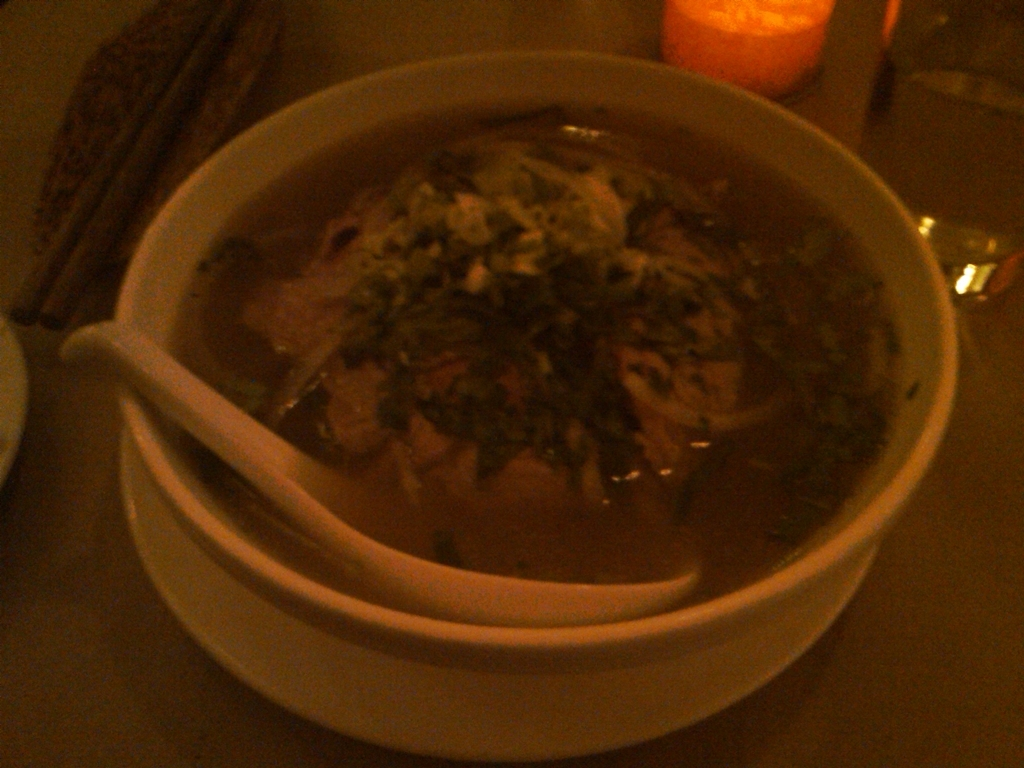Can you describe what is in the bowl? It looks like the bowl contains a type of soup, possibly a traditional noodle soup. I can identify what seems to be sliced meat, noodles, and a generous amount of herbs on top. However, due to the image's low clarity, specific ingredients are not easily discernable. What makes you think it's a traditional noodle soup? The visible elements such as the slices of meat, herbs, and strands resembling noodles suggest it's a traditional noodle soup. Such soups are common in various cuisines and often include these ingredients, along with a flavorful broth. 